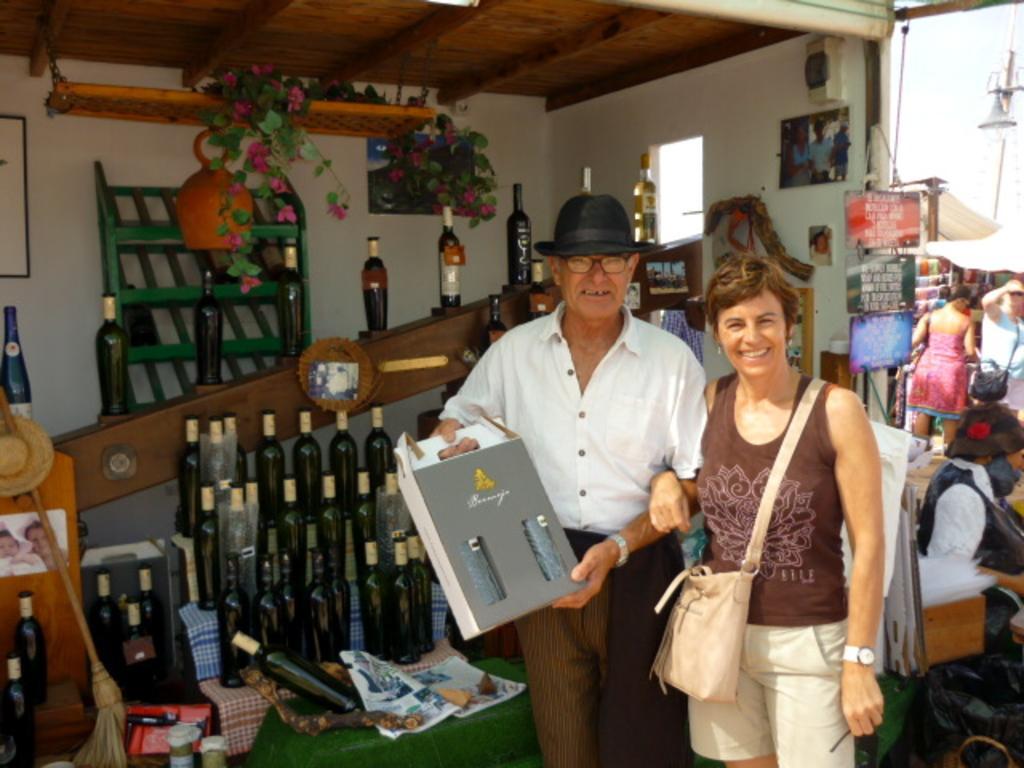Please provide a concise description of this image. This picture shows a man and woman standing. We see woman wore a handbag and man wore a hat on his head and spectacles and he is holding a box in his hand and we see a man seated on the side and we see few people are standing and we see couple of posters on the wall and we see wine bottles. 